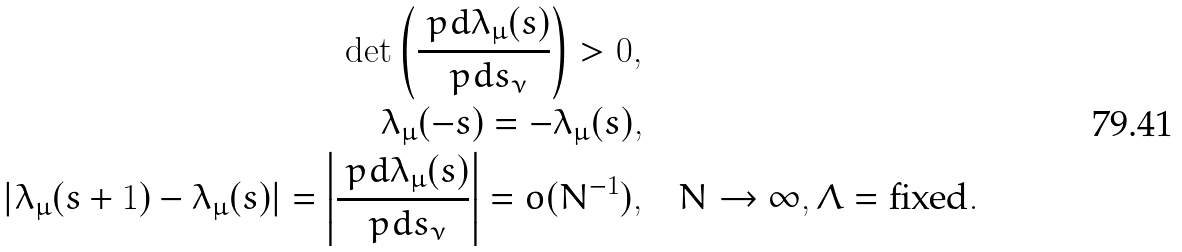<formula> <loc_0><loc_0><loc_500><loc_500>\det \left ( \frac { \ p d \lambda _ { \mu } ( s ) } { \ p d s _ { \nu } } \right ) > 0 , \quad & \\ \lambda _ { \mu } ( - s ) = - \lambda _ { \mu } ( s ) , \quad & \\ | \lambda _ { \mu } ( s + 1 ) - \lambda _ { \mu } ( s ) | = \left | \frac { \ p d \lambda _ { \mu } ( s ) } { \ p d s _ { \nu } } \right | = o ( N ^ { - 1 } ) , \quad & N \rightarrow \infty , \Lambda = \text {fixed} .</formula> 